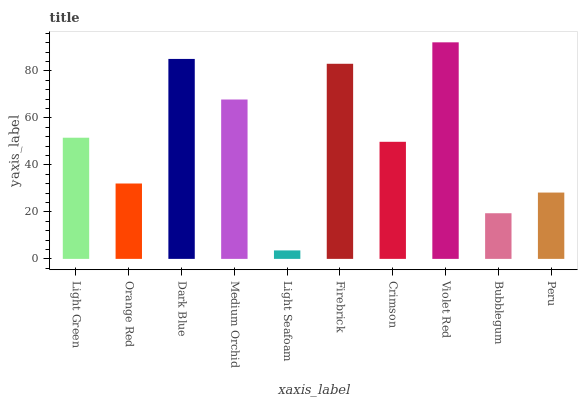Is Light Seafoam the minimum?
Answer yes or no. Yes. Is Violet Red the maximum?
Answer yes or no. Yes. Is Orange Red the minimum?
Answer yes or no. No. Is Orange Red the maximum?
Answer yes or no. No. Is Light Green greater than Orange Red?
Answer yes or no. Yes. Is Orange Red less than Light Green?
Answer yes or no. Yes. Is Orange Red greater than Light Green?
Answer yes or no. No. Is Light Green less than Orange Red?
Answer yes or no. No. Is Light Green the high median?
Answer yes or no. Yes. Is Crimson the low median?
Answer yes or no. Yes. Is Firebrick the high median?
Answer yes or no. No. Is Light Green the low median?
Answer yes or no. No. 